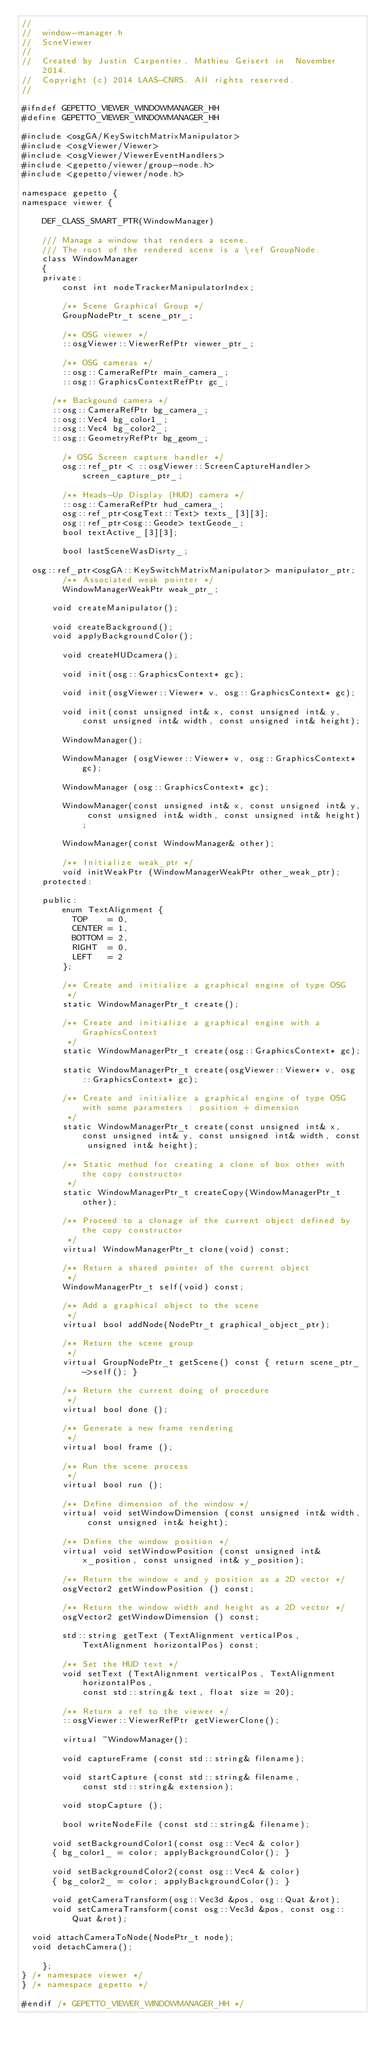Convert code to text. <code><loc_0><loc_0><loc_500><loc_500><_C_>//
//  window-manager.h
//  ScneViewer
//
//  Created by Justin Carpentier, Mathieu Geisert in  November 2014.
//  Copyright (c) 2014 LAAS-CNRS. All rights reserved.
//

#ifndef GEPETTO_VIEWER_WINDOWMANAGER_HH
#define GEPETTO_VIEWER_WINDOWMANAGER_HH

#include <osgGA/KeySwitchMatrixManipulator>
#include <osgViewer/Viewer>
#include <osgViewer/ViewerEventHandlers>
#include <gepetto/viewer/group-node.h>
#include <gepetto/viewer/node.h>

namespace gepetto {
namespace viewer {

    DEF_CLASS_SMART_PTR(WindowManager)

    /// Manage a window that renders a scene.
    /// The root of the rendered scene is a \ref GroupNode.
    class WindowManager
    {
    private:
        const int nodeTrackerManipulatorIndex;

        /** Scene Graphical Group */
        GroupNodePtr_t scene_ptr_;

        /** OSG viewer */
        ::osgViewer::ViewerRefPtr viewer_ptr_;

        /** OSG cameras */
        ::osg::CameraRefPtr main_camera_;
        ::osg::GraphicsContextRefPtr gc_;
      
      /** Backgound camera */
      ::osg::CameraRefPtr bg_camera_;
      ::osg::Vec4 bg_color1_;
      ::osg::Vec4 bg_color2_;
      ::osg::GeometryRefPtr bg_geom_;

        /* OSG Screen capture handler */
        osg::ref_ptr < ::osgViewer::ScreenCaptureHandler> screen_capture_ptr_;

        /** Heads-Up Display (HUD) camera */
        ::osg::CameraRefPtr hud_camera_;
        osg::ref_ptr<osgText::Text> texts_[3][3];
        osg::ref_ptr<osg::Geode> textGeode_;
        bool textActive_[3][3];

        bool lastSceneWasDisrty_;

	osg::ref_ptr<osgGA::KeySwitchMatrixManipulator> manipulator_ptr;
        /** Associated weak pointer */
        WindowManagerWeakPtr weak_ptr_;

      void createManipulator();
      
      void createBackground();
      void applyBackgroundColor();

        void createHUDcamera();

        void init(osg::GraphicsContext* gc);

        void init(osgViewer::Viewer* v, osg::GraphicsContext* gc);

        void init(const unsigned int& x, const unsigned int& y, const unsigned int& width, const unsigned int& height);

        WindowManager();

        WindowManager (osgViewer::Viewer* v, osg::GraphicsContext* gc);

        WindowManager (osg::GraphicsContext* gc);

        WindowManager(const unsigned int& x, const unsigned int& y, const unsigned int& width, const unsigned int& height);

        WindowManager(const WindowManager& other);

        /** Initialize weak_ptr */
        void initWeakPtr (WindowManagerWeakPtr other_weak_ptr);
    protected:

    public:
        enum TextAlignment {
          TOP    = 0,
          CENTER = 1,
          BOTTOM = 2,
          RIGHT  = 0,
          LEFT   = 2
        };

        /** Create and initialize a graphical engine of type OSG
         */
        static WindowManagerPtr_t create();

        /** Create and initialize a graphical engine with a GraphicsContext
         */
        static WindowManagerPtr_t create(osg::GraphicsContext* gc);

        static WindowManagerPtr_t create(osgViewer::Viewer* v, osg::GraphicsContext* gc);

        /** Create and initialize a graphical engine of type OSG with some parameters : position + dimension
         */
        static WindowManagerPtr_t create(const unsigned int& x, const unsigned int& y, const unsigned int& width, const unsigned int& height);

        /** Static method for creating a clone of box other with the copy constructor
         */
        static WindowManagerPtr_t createCopy(WindowManagerPtr_t other);

        /** Proceed to a clonage of the current object defined by the copy constructor
         */
        virtual WindowManagerPtr_t clone(void) const;

        /** Return a shared pointer of the current object
         */
        WindowManagerPtr_t self(void) const;

        /** Add a graphical object to the scene
         */
        virtual bool addNode(NodePtr_t graphical_object_ptr);

        /** Return the scene group
         */
        virtual GroupNodePtr_t getScene() const { return scene_ptr_->self(); }

        /** Return the current doing of procedure
         */
        virtual bool done ();

        /** Generate a new frame rendering
         */
        virtual bool frame ();

        /** Run the scene process
         */
        virtual bool run ();

        /** Define dimension of the window */
        virtual void setWindowDimension (const unsigned int& width, const unsigned int& height);

        /** Define the window position */
        virtual void setWindowPosition (const unsigned int& x_position, const unsigned int& y_position);

        /** Return the window x and y position as a 2D vector */
        osgVector2 getWindowPosition () const;

        /** Return the window width and height as a 2D vector */
        osgVector2 getWindowDimension () const;

        std::string getText (TextAlignment verticalPos, TextAlignment horizontalPos) const;

        /** Set the HUD text */
        void setText (TextAlignment verticalPos, TextAlignment horizontalPos,
            const std::string& text, float size = 20);

        /** Return a ref to the viewer */
        ::osgViewer::ViewerRefPtr getViewerClone();

        virtual ~WindowManager();

        void captureFrame (const std::string& filename);

        void startCapture (const std::string& filename,
            const std::string& extension);

        void stopCapture ();

        bool writeNodeFile (const std::string& filename);
        
      void setBackgroundColor1(const osg::Vec4 & color)
      { bg_color1_ = color; applyBackgroundColor(); }
        
      void setBackgroundColor2(const osg::Vec4 & color)
      { bg_color2_ = color; applyBackgroundColor(); }

      void getCameraTransform(osg::Vec3d &pos, osg::Quat &rot);
      void setCameraTransform(const osg::Vec3d &pos, const osg::Quat &rot);

	void attachCameraToNode(NodePtr_t node);
	void detachCamera();

    };
} /* namespace viewer */
} /* namespace gepetto */

#endif /* GEPETTO_VIEWER_WINDOWMANAGER_HH */
</code> 